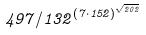<formula> <loc_0><loc_0><loc_500><loc_500>4 9 7 / 1 3 2 ^ { ( 7 \cdot 1 5 2 ) ^ { \sqrt { 2 0 2 } } }</formula> 